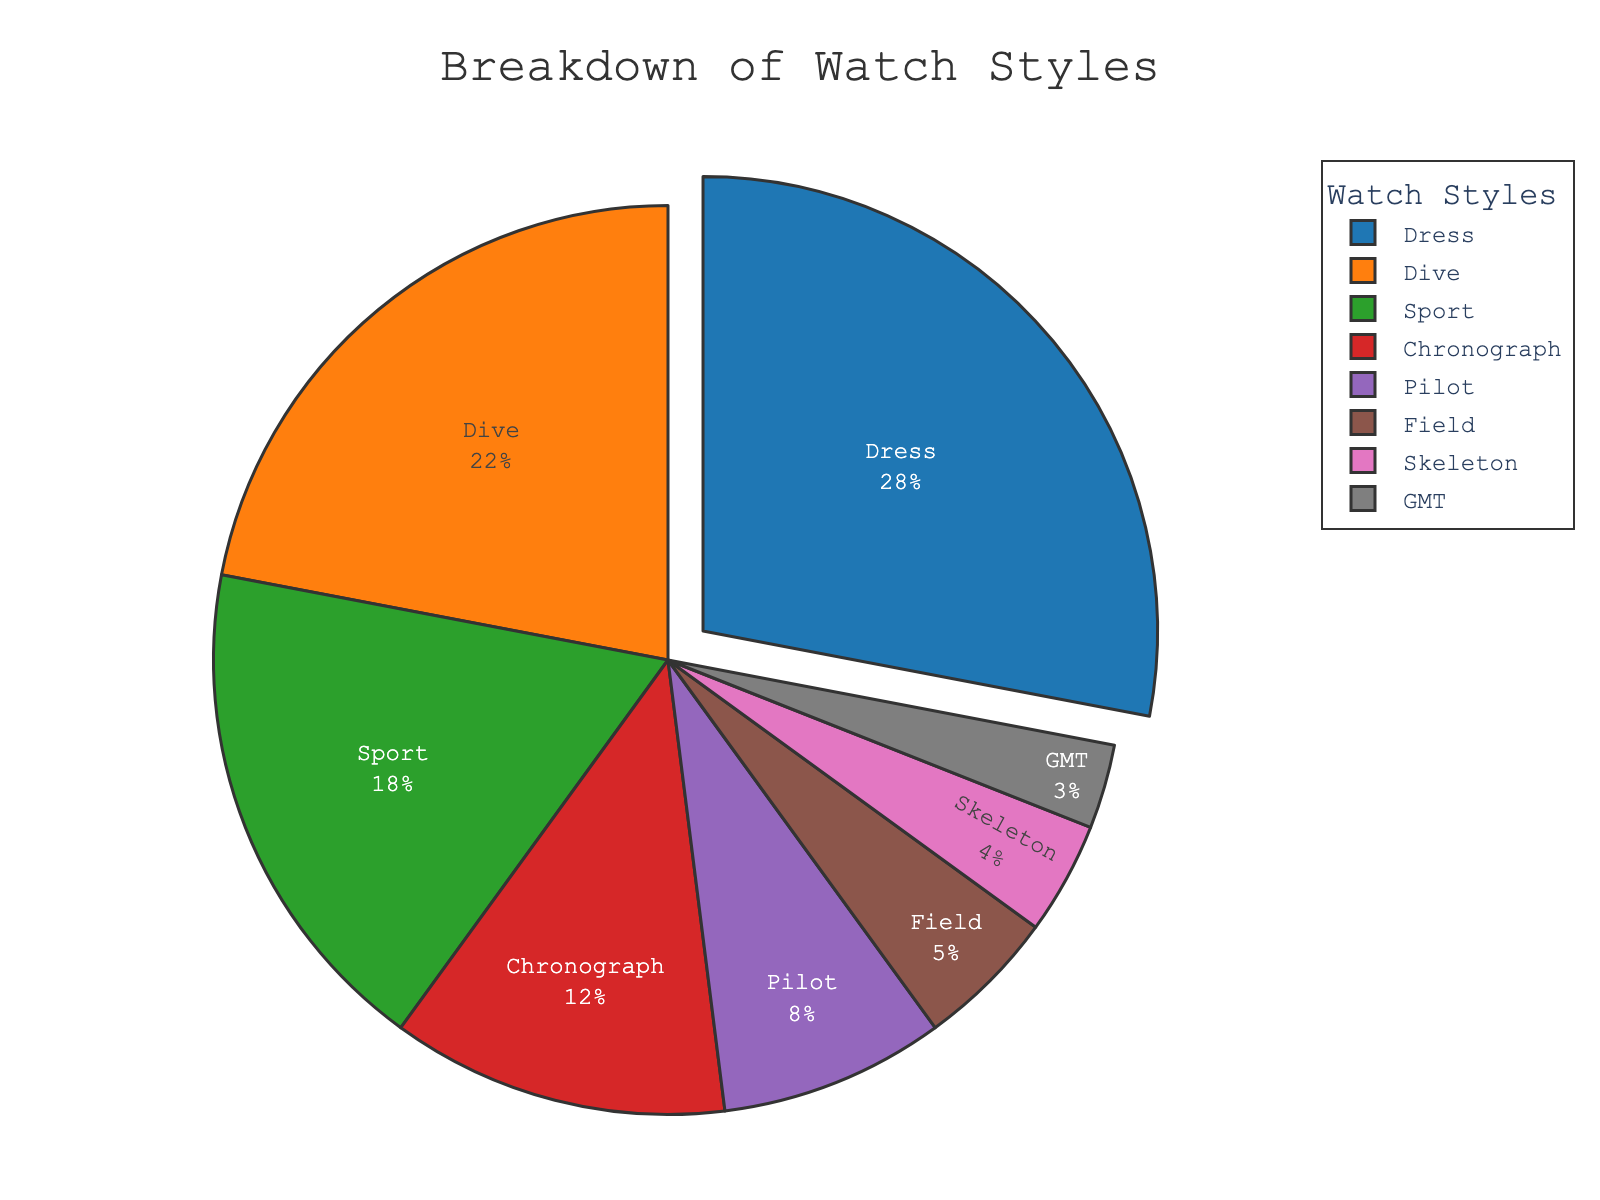What style of watch has the highest percentage? The figure shows a pie chart with different segments representing various watch styles. The segment labeled 'Dress' is the largest and accounts for 28%, which is the highest percentage.
Answer: Dress Which watch styles have a combined percentage greater than 30%? By adding the percentages of watch styles, we find that the combined percentage of Dress (28%) and any other style will exceed 30%. Adding Dive (22%) to Dress gives 50%.
Answer: Dress and Dive What is the difference in percentage between Sport and Dive watch styles? By referring to the pie chart, the percentage for Sport watches is 18% and for Dive watches is 22%. The difference is calculated as 22% - 18%.
Answer: 4% Which style has a smaller percentage, Pilot or Chronograph watches? By comparing the segments in the pie chart, the segment labeled 'Pilot' is smaller with 8%, while 'Chronograph' has 12%.
Answer: Pilot Are the combined percentages of Field and Skeleton watches greater than the percentage of Sport watches? From the pie chart, Field watches have 5% and Skeleton watches have 4%. Their combined percentage is 5% + 4% = 9%, which is less than the Sport watch percentage of 18%.
Answer: No Which watch style is represented by the green-colored segment? According to the visual attributes of the pie chart, the green color represents the Sport watch segment.
Answer: Sport If the combined percentage of Dress and Chronograph watches were doubled, what would it be? The percentage of Dress watches is 28% and Chronograph watches is 12%. Their combined percentage is 28% + 12% = 40%. Doubling this combined percentage would be 2 * 40%.
Answer: 80% How many styles have a percentage lower than 10%? By analyzing the segments in the pie chart, the watch styles with percentages lower than 10% are Pilot (8%), Field (5%), Skeleton (4%), and GMT (3%), making a total of 4 styles.
Answer: 4 What is the average percentage of Chronograph and GMT watch styles? The percentage for Chronograph watches is 12% and for GMT watches is 3%. The average is calculated by (12% + 3%) / 2.
Answer: 7.5% If you were to remove the Dress style, what would be the new total percentage of the remaining styles? The Dress style accounts for 28%. Removing it from the total 100% leaves 100% - 28% = 72% for the remaining styles.
Answer: 72% 